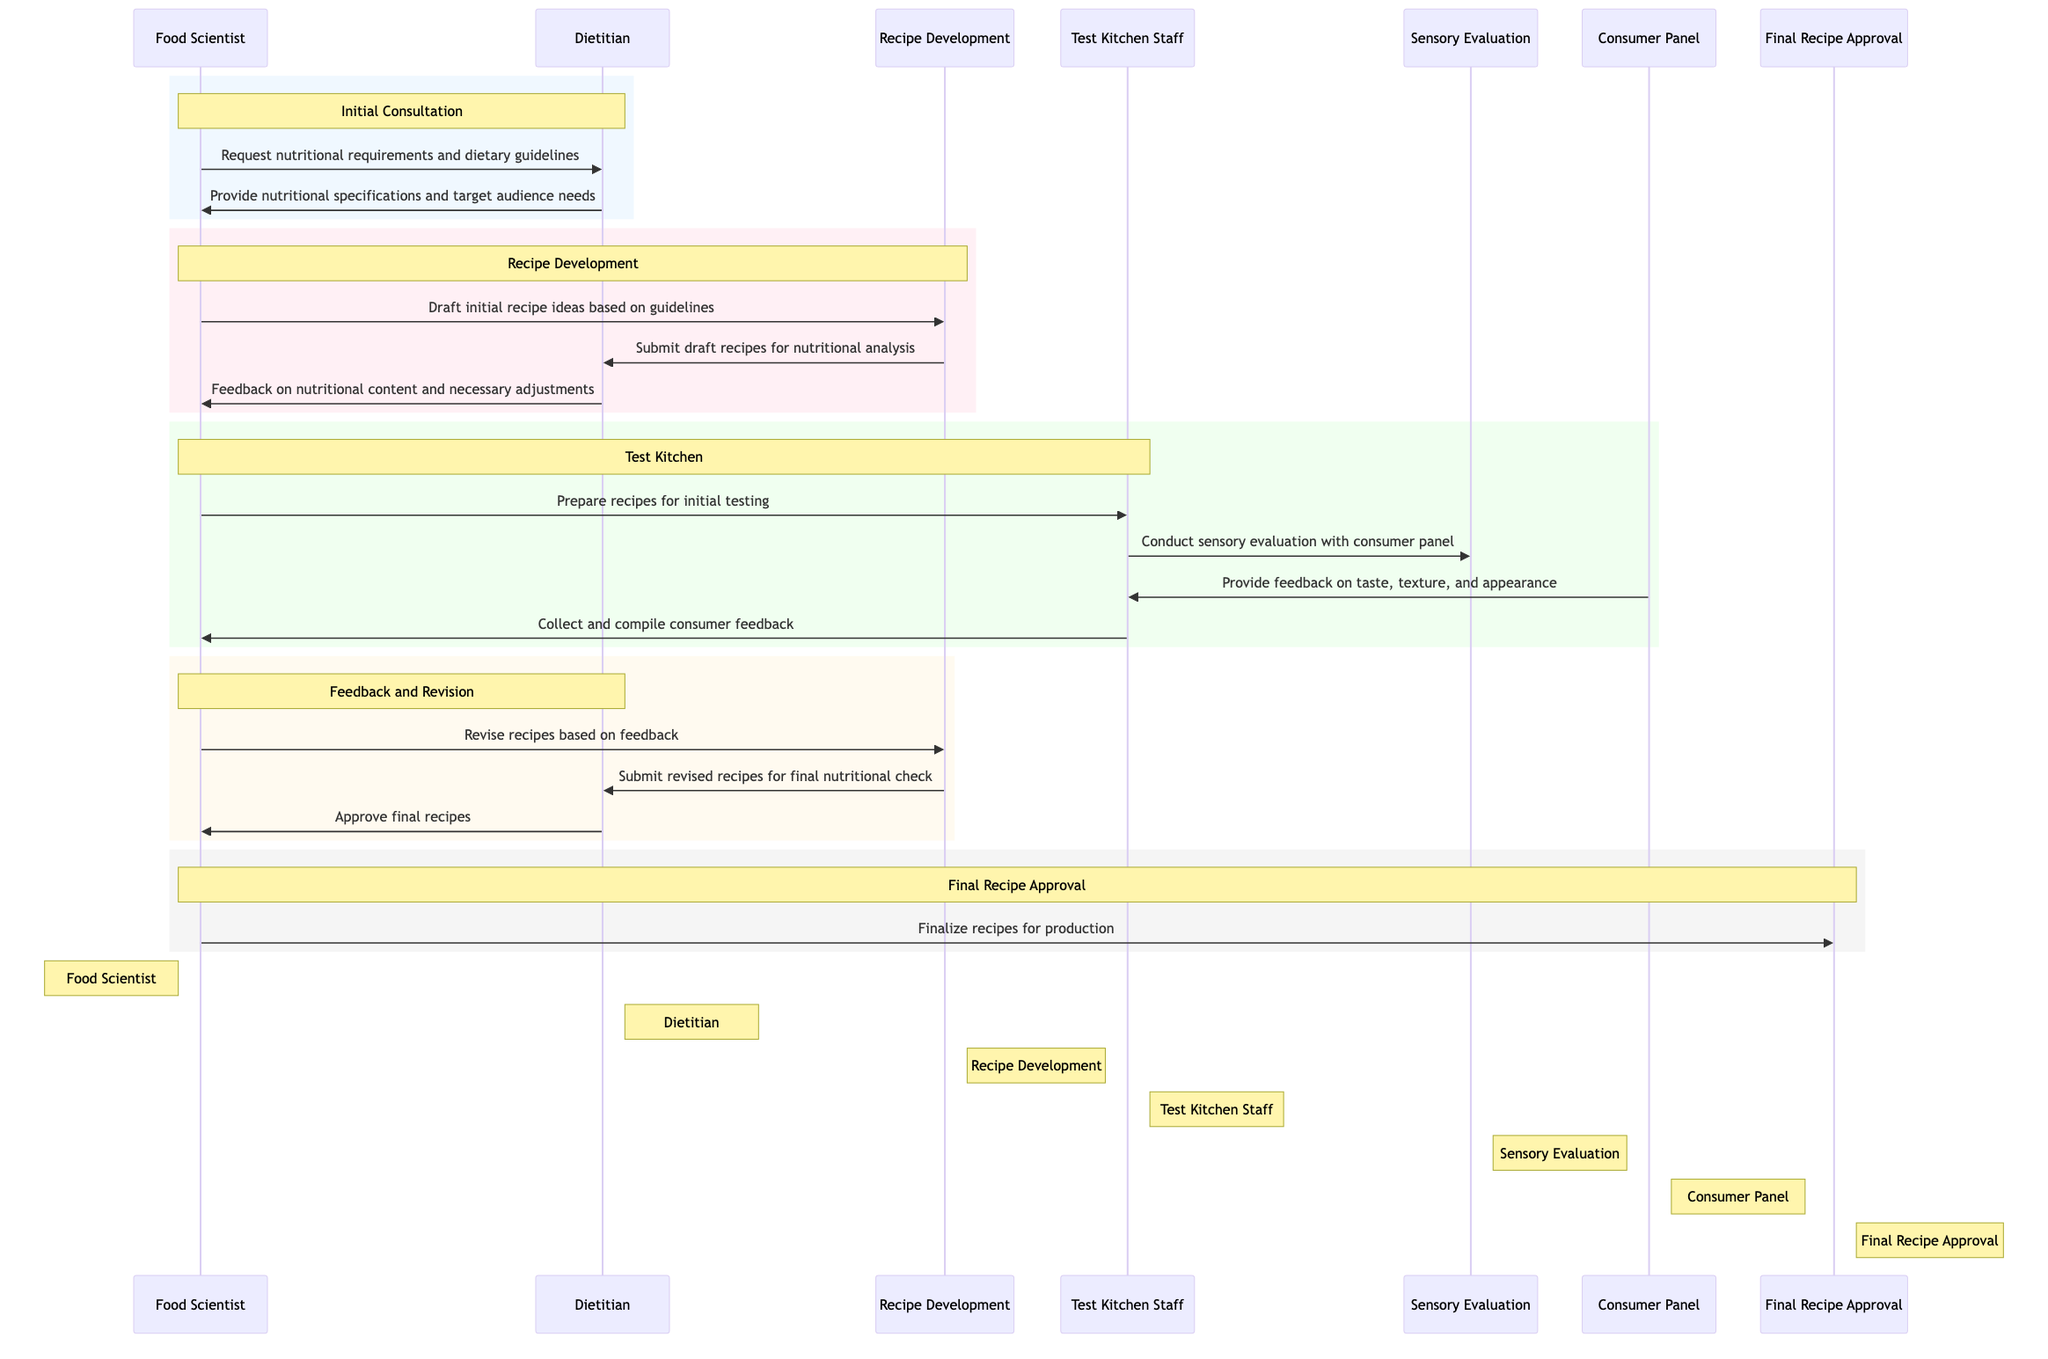What is the first action in the sequence? The first action in the sequence is "Request nutritional requirements and dietary guidelines" from the Food Scientist to the Dietitian. This can be identified by looking at the timeline where the Food Scientist initiates the conversation in the initial consultation section.
Answer: Request nutritional requirements and dietary guidelines How many lifelines are present in the diagram? The lifelines in the diagram represent distinct roles in the collaboration process. There are a total of 7 lifelines, which include the Food Scientist, Dietitian, Recipe Development, Test Kitchen Staff, Sensory Evaluation, Consumer Panel, and Final Recipe Approval. Each of these represents a different phase or actor in the recipe development process.
Answer: 7 What does the Dietitian provide after receiving the initial request? After receiving the request from the Food Scientist, the Dietitian provides "nutritional specifications and target audience needs." This directly follows the request and outlines the key responsibilities the Dietitian holds in the collaboration.
Answer: Nutritional specifications and target audience needs Which role conducts the sensory evaluation? The sensory evaluation role is conducted by the "Test Kitchen Staff," who take the prepared recipes and evaluate them with input from the Consumer Panel. This is specified in the Test Kitchen section of the diagram where the Test Kitchen Staff are involved in evaluating the recipes.
Answer: Test Kitchen Staff What happens after the consumer panel feedback is collected? Once the consumer panel feedback is collected, the Test Kitchen Staff compile this information and send it back to the Food Scientist, who then revises the recipes based on this feedback. The flow can be traced through the Test Kitchen and Feedback and Revision sections.
Answer: Revise recipes based on feedback Which step comes immediately before final recipe approval? The step immediately before final recipe approval is when the Food Scientist submits the revised recipes for a final nutritional check to the Dietitian, who then approves the final recipes. This sequential relationship is evident in the Feedback and Revision section just prior to the final recipe approval.
Answer: Submit revised recipes for final nutritional check How many feedback loops are portrayed in this sequence? The diagram shows one main feedback loop that occurs when the Dietitian provides feedback after the initial draft recipes, leading to revisions by the Food Scientist, followed again by the Dietitian's approval of revised recipes before finalization. This loop illustrates an essential iterative process typical in recipe development.
Answer: 1 What triggers the recipe finalization process? The recipe finalization process is triggered by the Dietitian's approval of the final recipes. After this approval, the Food Scientist moves on to finalize recipes for production, indicating a direct cause-and-effect relationship in the process illustrated in the diagram.
Answer: Approve final recipes 